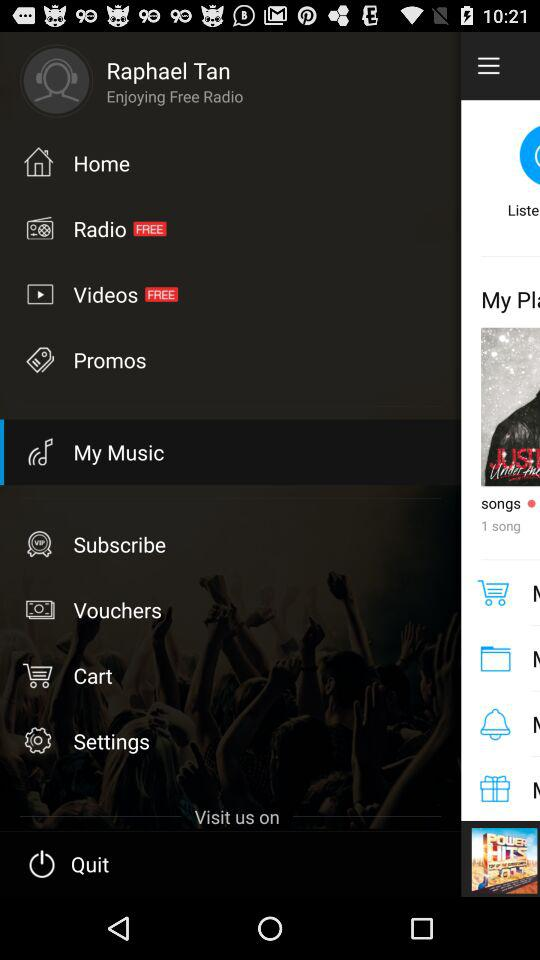What options are free? The free options are "Radio" and "Videos". 